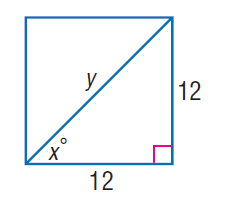Question: Find x.
Choices:
A. 30
B. 45
C. 60
D. 90
Answer with the letter. Answer: B Question: Find y.
Choices:
A. 6
B. 9
C. 12
D. 12 \sqrt { 2 }
Answer with the letter. Answer: D 